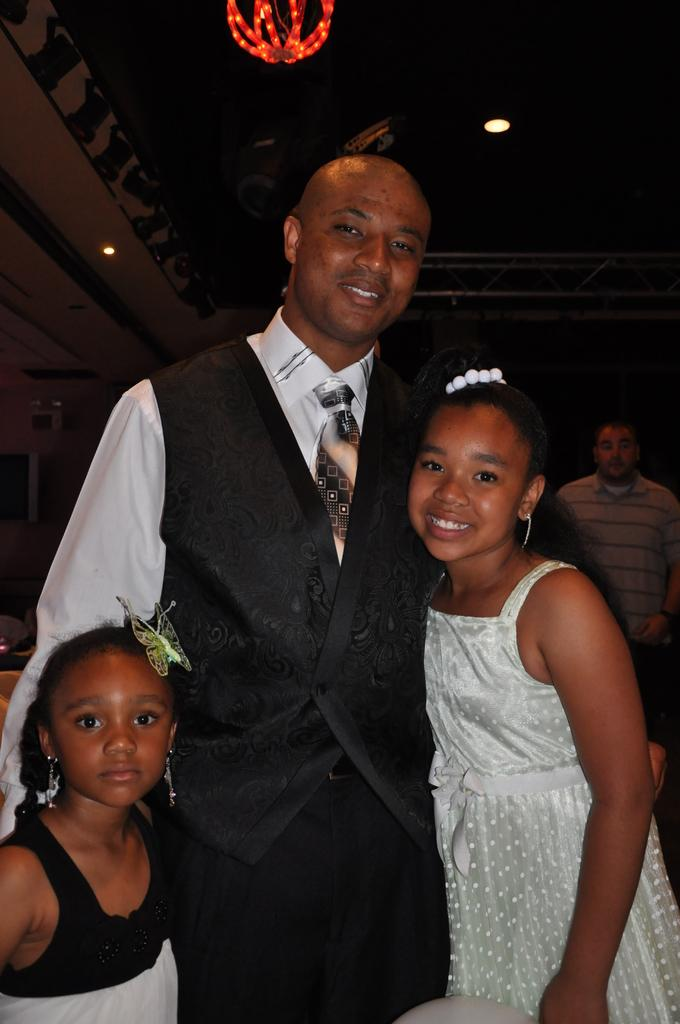Who is the main subject in the image? There is a man in the image. What is the man doing in the image? The man is posing for the camera and smiling. How many kids are in the image? There are two kids in the image. What are the kids doing in the image? The kids are smiling. Can you describe the person behind the man? There is another person behind the man, but their appearance or actions are not specified. What is visible at the top of the image? There is a lamp visible at the top of the image. What type of hospital is visible in the image? There is no hospital present in the image. 